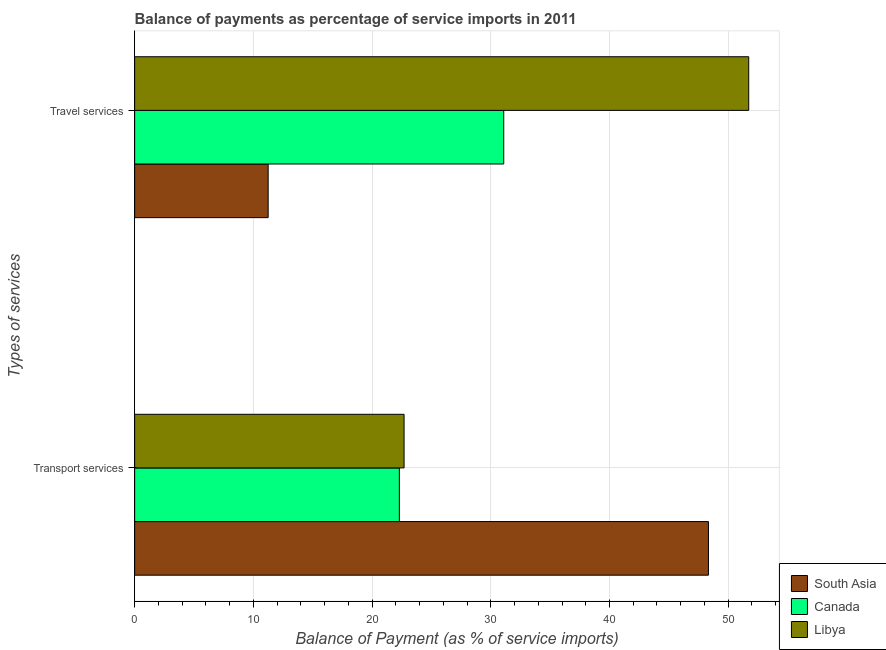How many groups of bars are there?
Provide a short and direct response. 2. Are the number of bars per tick equal to the number of legend labels?
Provide a succinct answer. Yes. Are the number of bars on each tick of the Y-axis equal?
Make the answer very short. Yes. How many bars are there on the 1st tick from the bottom?
Keep it short and to the point. 3. What is the label of the 2nd group of bars from the top?
Give a very brief answer. Transport services. What is the balance of payments of transport services in Libya?
Ensure brevity in your answer.  22.7. Across all countries, what is the maximum balance of payments of travel services?
Provide a succinct answer. 51.73. Across all countries, what is the minimum balance of payments of travel services?
Provide a short and direct response. 11.25. In which country was the balance of payments of transport services maximum?
Provide a succinct answer. South Asia. What is the total balance of payments of transport services in the graph?
Your answer should be compact. 93.33. What is the difference between the balance of payments of transport services in South Asia and that in Canada?
Offer a very short reply. 26.04. What is the difference between the balance of payments of travel services in Canada and the balance of payments of transport services in Libya?
Offer a terse response. 8.4. What is the average balance of payments of travel services per country?
Ensure brevity in your answer.  31.36. What is the difference between the balance of payments of transport services and balance of payments of travel services in Libya?
Your answer should be very brief. -29.03. In how many countries, is the balance of payments of transport services greater than 22 %?
Provide a succinct answer. 3. What is the ratio of the balance of payments of transport services in Libya to that in Canada?
Ensure brevity in your answer.  1.02. In how many countries, is the balance of payments of travel services greater than the average balance of payments of travel services taken over all countries?
Give a very brief answer. 1. What does the 3rd bar from the top in Transport services represents?
Ensure brevity in your answer.  South Asia. Are all the bars in the graph horizontal?
Ensure brevity in your answer.  Yes. How many countries are there in the graph?
Keep it short and to the point. 3. What is the difference between two consecutive major ticks on the X-axis?
Ensure brevity in your answer.  10. Are the values on the major ticks of X-axis written in scientific E-notation?
Provide a succinct answer. No. How many legend labels are there?
Provide a succinct answer. 3. How are the legend labels stacked?
Make the answer very short. Vertical. What is the title of the graph?
Offer a very short reply. Balance of payments as percentage of service imports in 2011. What is the label or title of the X-axis?
Provide a short and direct response. Balance of Payment (as % of service imports). What is the label or title of the Y-axis?
Your answer should be very brief. Types of services. What is the Balance of Payment (as % of service imports) of South Asia in Transport services?
Keep it short and to the point. 48.34. What is the Balance of Payment (as % of service imports) in Canada in Transport services?
Your answer should be very brief. 22.3. What is the Balance of Payment (as % of service imports) of Libya in Transport services?
Keep it short and to the point. 22.7. What is the Balance of Payment (as % of service imports) of South Asia in Travel services?
Your response must be concise. 11.25. What is the Balance of Payment (as % of service imports) in Canada in Travel services?
Offer a very short reply. 31.09. What is the Balance of Payment (as % of service imports) in Libya in Travel services?
Ensure brevity in your answer.  51.73. Across all Types of services, what is the maximum Balance of Payment (as % of service imports) of South Asia?
Make the answer very short. 48.34. Across all Types of services, what is the maximum Balance of Payment (as % of service imports) in Canada?
Ensure brevity in your answer.  31.09. Across all Types of services, what is the maximum Balance of Payment (as % of service imports) of Libya?
Offer a very short reply. 51.73. Across all Types of services, what is the minimum Balance of Payment (as % of service imports) of South Asia?
Keep it short and to the point. 11.25. Across all Types of services, what is the minimum Balance of Payment (as % of service imports) of Canada?
Provide a succinct answer. 22.3. Across all Types of services, what is the minimum Balance of Payment (as % of service imports) of Libya?
Your response must be concise. 22.7. What is the total Balance of Payment (as % of service imports) of South Asia in the graph?
Offer a very short reply. 59.58. What is the total Balance of Payment (as % of service imports) of Canada in the graph?
Offer a terse response. 53.39. What is the total Balance of Payment (as % of service imports) in Libya in the graph?
Keep it short and to the point. 74.43. What is the difference between the Balance of Payment (as % of service imports) of South Asia in Transport services and that in Travel services?
Your answer should be compact. 37.09. What is the difference between the Balance of Payment (as % of service imports) in Canada in Transport services and that in Travel services?
Provide a short and direct response. -8.79. What is the difference between the Balance of Payment (as % of service imports) of Libya in Transport services and that in Travel services?
Your answer should be compact. -29.03. What is the difference between the Balance of Payment (as % of service imports) of South Asia in Transport services and the Balance of Payment (as % of service imports) of Canada in Travel services?
Offer a terse response. 17.24. What is the difference between the Balance of Payment (as % of service imports) in South Asia in Transport services and the Balance of Payment (as % of service imports) in Libya in Travel services?
Make the answer very short. -3.39. What is the difference between the Balance of Payment (as % of service imports) in Canada in Transport services and the Balance of Payment (as % of service imports) in Libya in Travel services?
Offer a very short reply. -29.43. What is the average Balance of Payment (as % of service imports) of South Asia per Types of services?
Give a very brief answer. 29.79. What is the average Balance of Payment (as % of service imports) in Canada per Types of services?
Give a very brief answer. 26.7. What is the average Balance of Payment (as % of service imports) of Libya per Types of services?
Provide a succinct answer. 37.21. What is the difference between the Balance of Payment (as % of service imports) of South Asia and Balance of Payment (as % of service imports) of Canada in Transport services?
Keep it short and to the point. 26.04. What is the difference between the Balance of Payment (as % of service imports) of South Asia and Balance of Payment (as % of service imports) of Libya in Transport services?
Make the answer very short. 25.64. What is the difference between the Balance of Payment (as % of service imports) of Canada and Balance of Payment (as % of service imports) of Libya in Transport services?
Make the answer very short. -0.4. What is the difference between the Balance of Payment (as % of service imports) in South Asia and Balance of Payment (as % of service imports) in Canada in Travel services?
Provide a succinct answer. -19.85. What is the difference between the Balance of Payment (as % of service imports) in South Asia and Balance of Payment (as % of service imports) in Libya in Travel services?
Offer a very short reply. -40.48. What is the difference between the Balance of Payment (as % of service imports) of Canada and Balance of Payment (as % of service imports) of Libya in Travel services?
Give a very brief answer. -20.64. What is the ratio of the Balance of Payment (as % of service imports) in South Asia in Transport services to that in Travel services?
Your answer should be very brief. 4.3. What is the ratio of the Balance of Payment (as % of service imports) in Canada in Transport services to that in Travel services?
Provide a succinct answer. 0.72. What is the ratio of the Balance of Payment (as % of service imports) of Libya in Transport services to that in Travel services?
Ensure brevity in your answer.  0.44. What is the difference between the highest and the second highest Balance of Payment (as % of service imports) in South Asia?
Make the answer very short. 37.09. What is the difference between the highest and the second highest Balance of Payment (as % of service imports) in Canada?
Your response must be concise. 8.79. What is the difference between the highest and the second highest Balance of Payment (as % of service imports) of Libya?
Provide a succinct answer. 29.03. What is the difference between the highest and the lowest Balance of Payment (as % of service imports) in South Asia?
Offer a terse response. 37.09. What is the difference between the highest and the lowest Balance of Payment (as % of service imports) of Canada?
Your answer should be compact. 8.79. What is the difference between the highest and the lowest Balance of Payment (as % of service imports) in Libya?
Offer a very short reply. 29.03. 